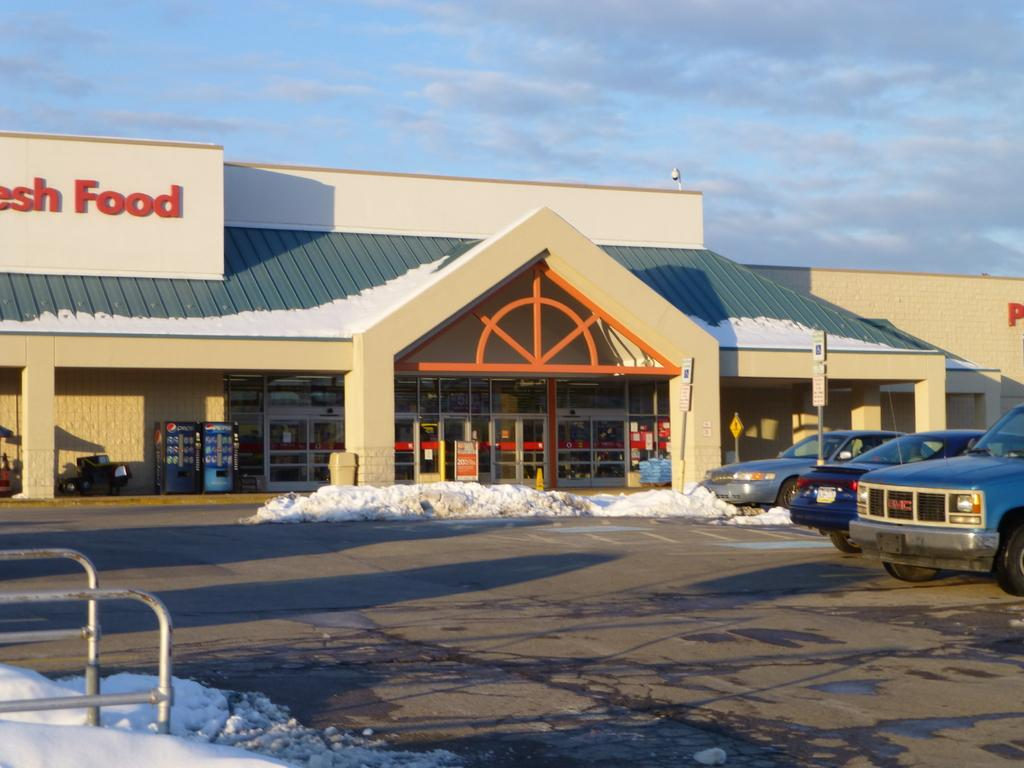What can be seen on the road in the image? There are vehicles on the road in the image. What is in front of the store? There are boards, a bin, snow, and signboards in front of the store. What type of advertisement is present in the image? This is a hoarding in the image. What is the weather like in the image? The sky is cloudy in the image. What else is visible in the image? There are rods visible in the image. What type of game is being played on the side of the road in the image? There is no game being played on the side of the road in the image. What color is the sock hanging on the rods in the image? There are no socks present in the image. 